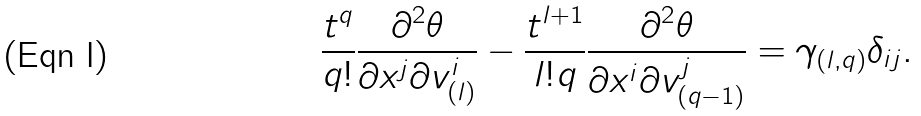Convert formula to latex. <formula><loc_0><loc_0><loc_500><loc_500>\frac { t ^ { q } } { q ! } \frac { \partial ^ { 2 } \theta } { \partial x ^ { j } \partial v _ { ( l ) } ^ { i } } - \frac { t ^ { l + 1 } } { l ! q } \frac { \partial ^ { 2 } \theta } { \partial x ^ { i } \partial v _ { ( q - 1 ) } ^ { j } } = \gamma _ { ( l , q ) } \delta _ { i j } .</formula> 